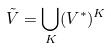<formula> <loc_0><loc_0><loc_500><loc_500>\tilde { V } = \bigcup _ { K } ( V ^ { * } ) ^ { K }</formula> 